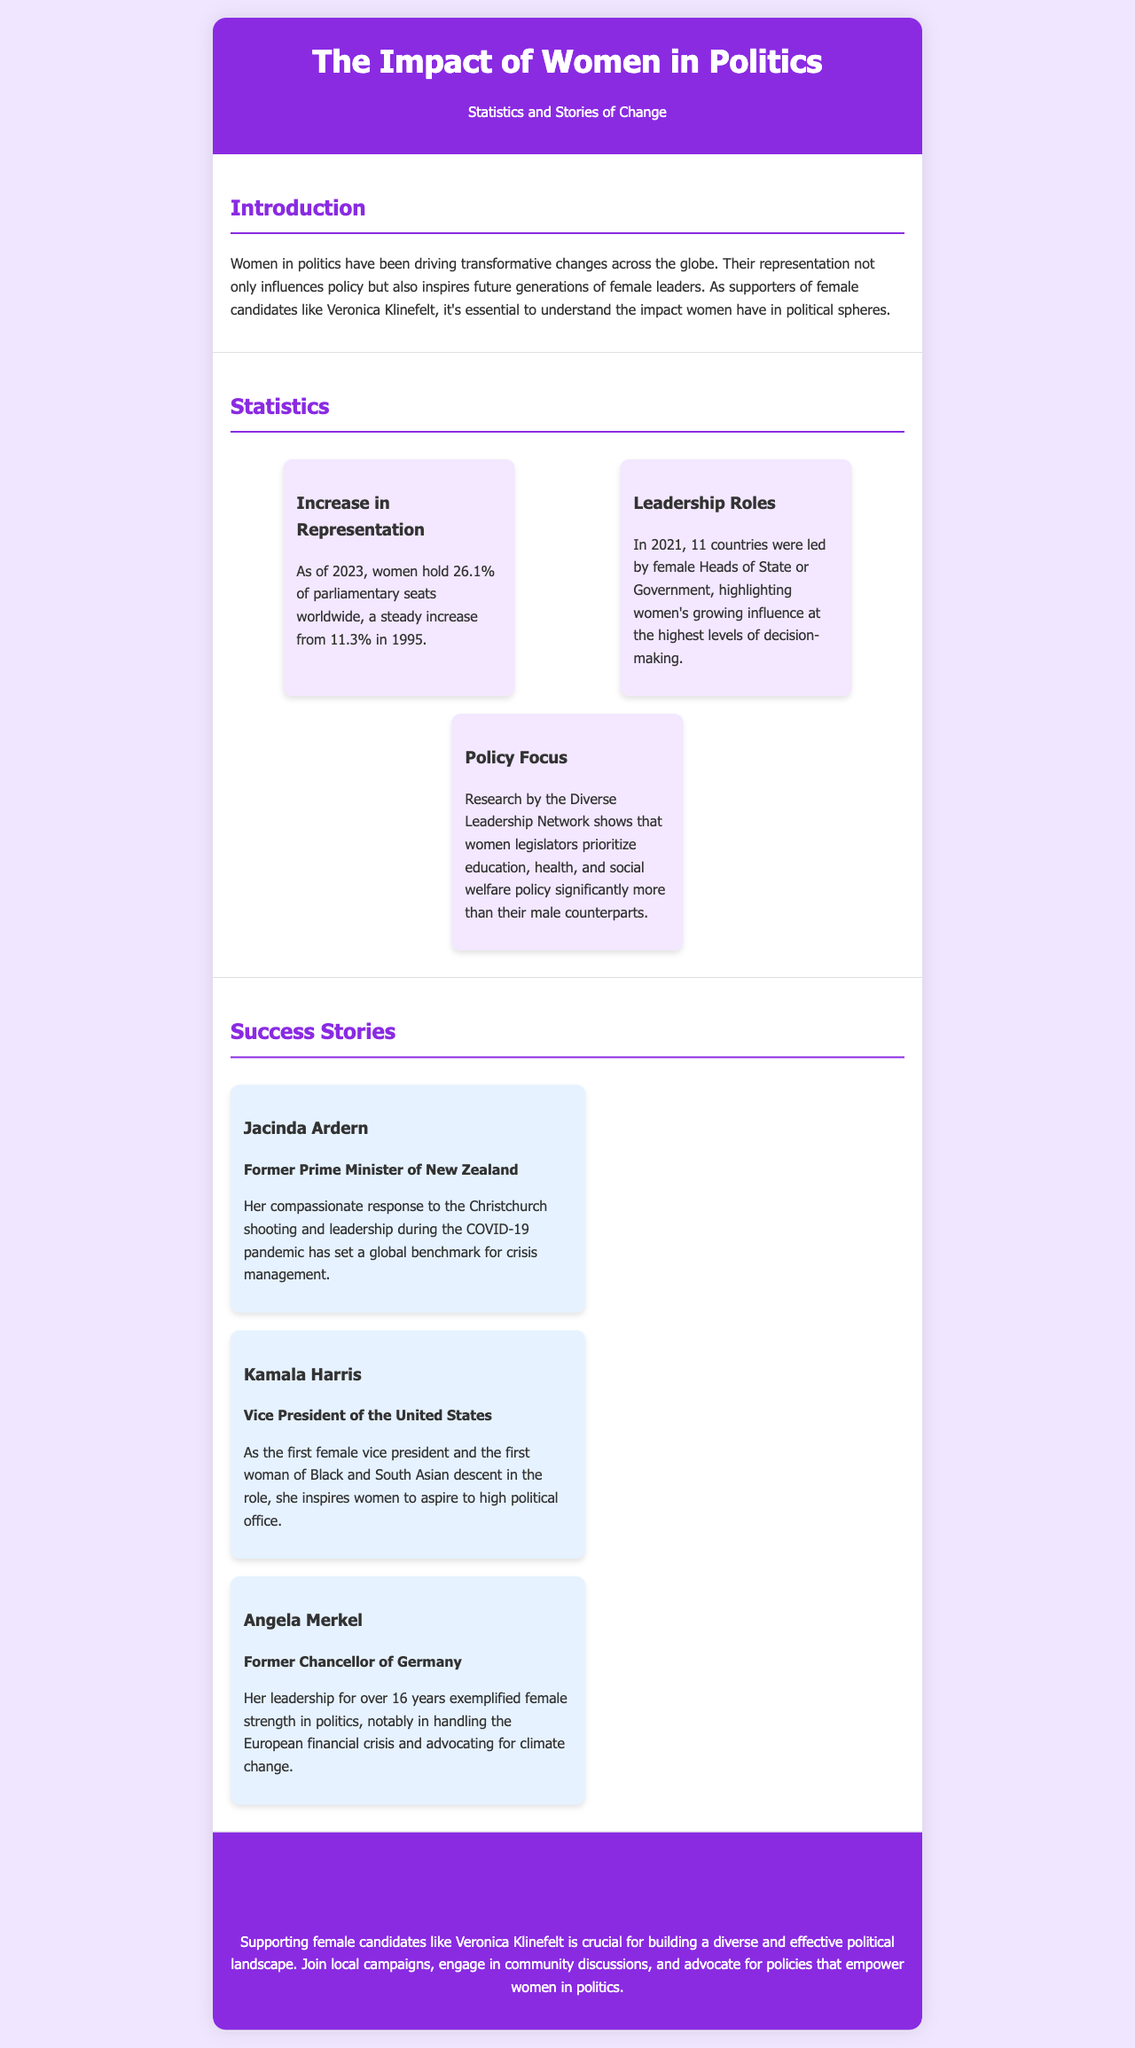What percentage of parliamentary seats do women hold as of 2023? The document states that as of 2023, women hold 26.1% of parliamentary seats worldwide.
Answer: 26.1% What year did women hold 11.3% of parliamentary seats? The document mentions that women held 11.3% of parliamentary seats in 1995.
Answer: 1995 Who was the first female Vice President of the United States? The document identifies Kamala Harris as the first female Vice President and the first woman of Black and South Asian descent in that role.
Answer: Kamala Harris Which policy areas do women legislators prioritize more than men according to the research? The document indicates that women legislators prioritize education, health, and social welfare policy significantly more than their male counterparts.
Answer: Education, health, social welfare What was Jacinda Ardern recognized for during her leadership? According to the document, Jacinda Ardern was recognized for her compassionate response to the Christchurch shooting and leadership during the COVID-19 pandemic.
Answer: Crisis management How many countries were led by female Heads of State or Government in 2021? The brochure states that in 2021, 11 countries were led by female Heads of State or Government.
Answer: 11 What is the call to action regarding supporting female candidates? The document emphasizes that supporting female candidates like Veronica Klinefelt is crucial for building a diverse and effective political landscape.
Answer: Support female candidates What does the document highlight about women's impact in political spheres? The document explains that women's representation influences policy and inspires future generations of female leaders.
Answer: Inspires future generations 